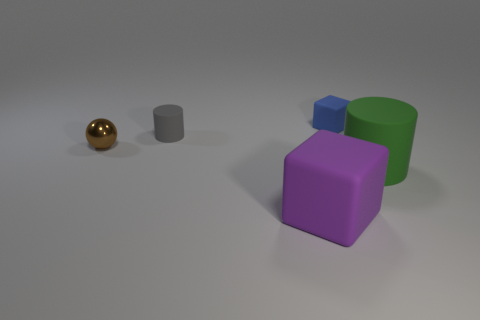Add 4 small things. How many objects exist? 9 Subtract 1 cylinders. How many cylinders are left? 1 Add 3 metallic objects. How many metallic objects are left? 4 Add 4 tiny metal spheres. How many tiny metal spheres exist? 5 Subtract 1 gray cylinders. How many objects are left? 4 Subtract all cylinders. How many objects are left? 3 Subtract all green cubes. Subtract all blue spheres. How many cubes are left? 2 Subtract all gray spheres. How many gray cylinders are left? 1 Subtract all big matte objects. Subtract all green objects. How many objects are left? 2 